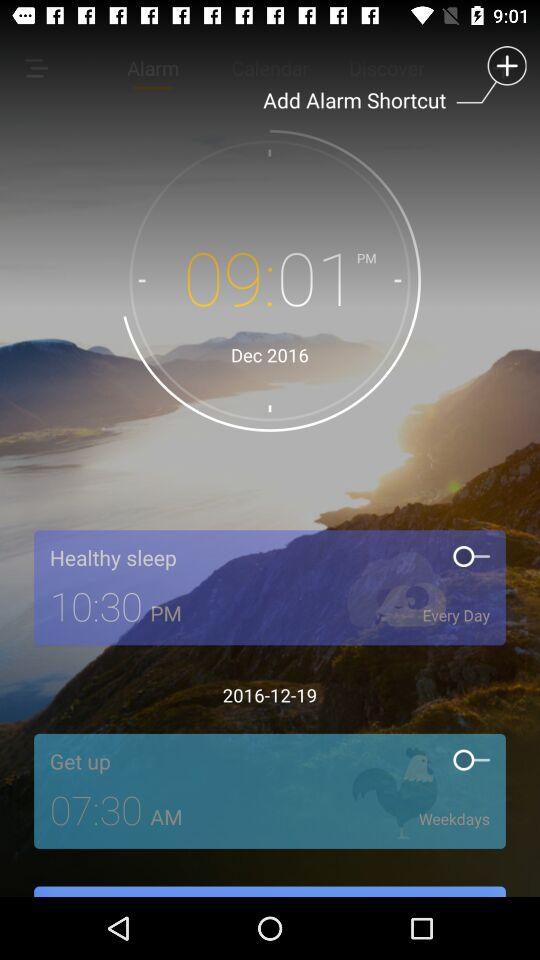How many days are included in the alarm for 'Get up'?
Answer the question using a single word or phrase. Weekdays 